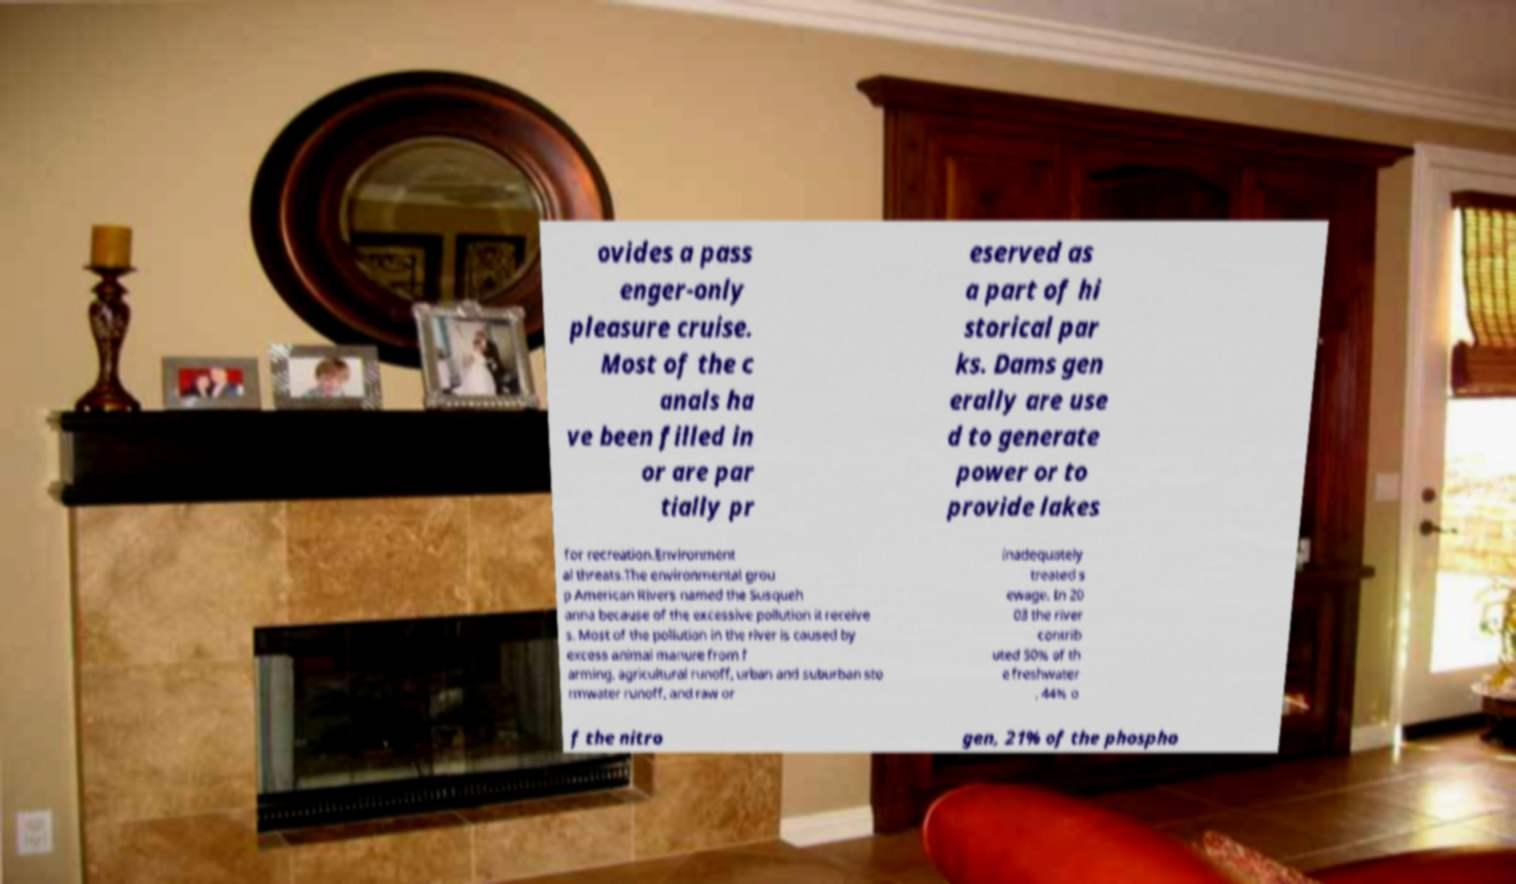Can you read and provide the text displayed in the image?This photo seems to have some interesting text. Can you extract and type it out for me? ovides a pass enger-only pleasure cruise. Most of the c anals ha ve been filled in or are par tially pr eserved as a part of hi storical par ks. Dams gen erally are use d to generate power or to provide lakes for recreation.Environment al threats.The environmental grou p American Rivers named the Susqueh anna because of the excessive pollution it receive s. Most of the pollution in the river is caused by excess animal manure from f arming, agricultural runoff, urban and suburban sto rmwater runoff, and raw or inadequately treated s ewage. In 20 03 the river contrib uted 50% of th e freshwater , 44% o f the nitro gen, 21% of the phospho 